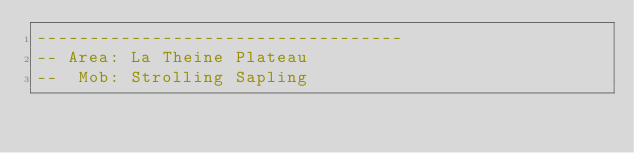Convert code to text. <code><loc_0><loc_0><loc_500><loc_500><_Lua_>-----------------------------------
-- Area: La Theine Plateau
--  Mob: Strolling Sapling</code> 